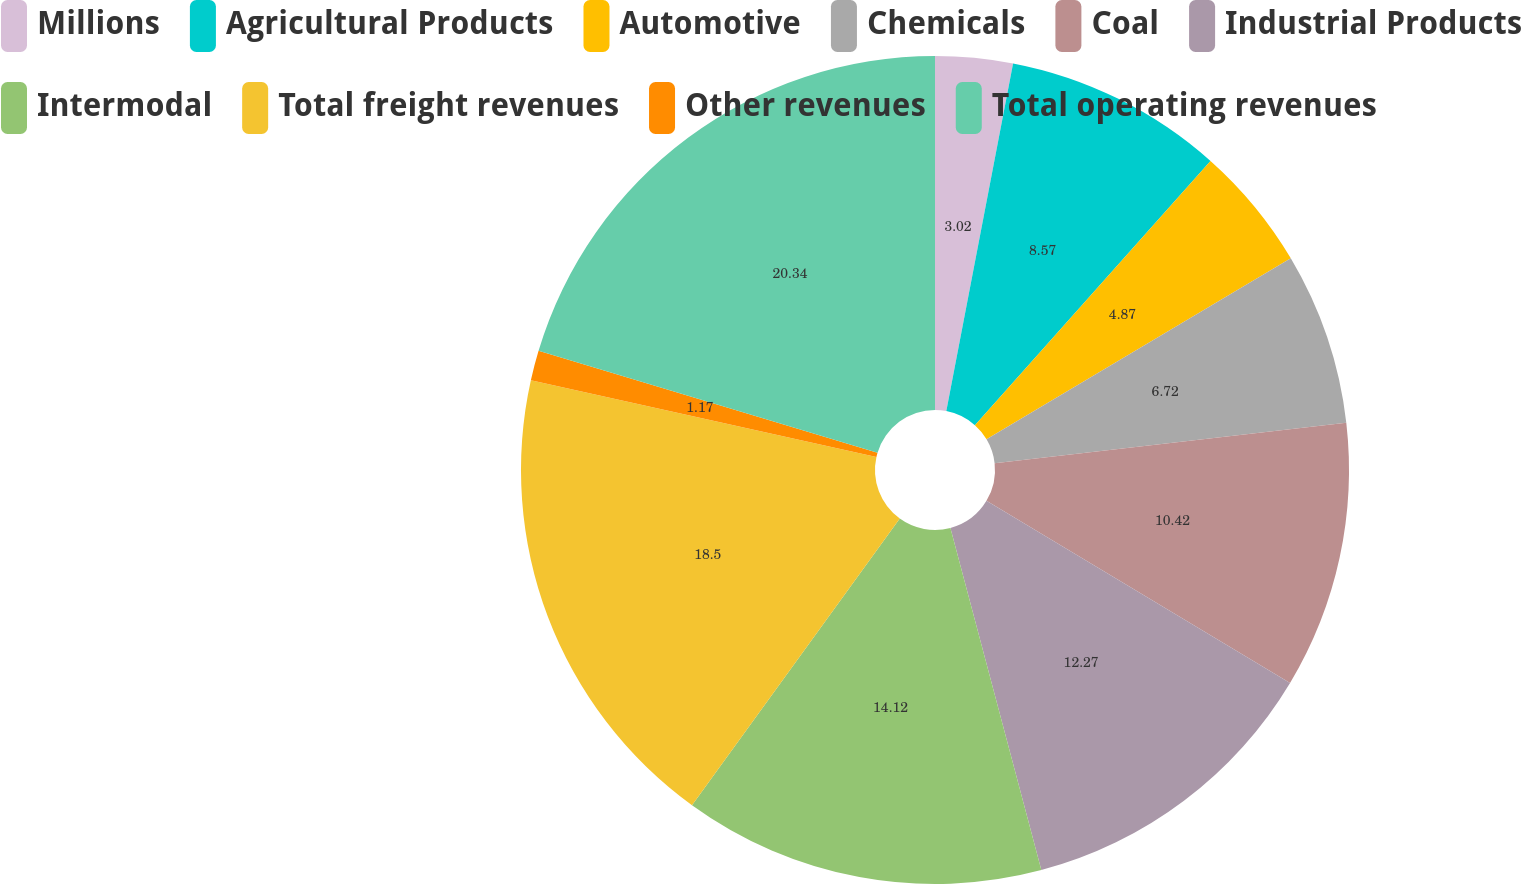Convert chart. <chart><loc_0><loc_0><loc_500><loc_500><pie_chart><fcel>Millions<fcel>Agricultural Products<fcel>Automotive<fcel>Chemicals<fcel>Coal<fcel>Industrial Products<fcel>Intermodal<fcel>Total freight revenues<fcel>Other revenues<fcel>Total operating revenues<nl><fcel>3.02%<fcel>8.57%<fcel>4.87%<fcel>6.72%<fcel>10.42%<fcel>12.27%<fcel>14.12%<fcel>18.5%<fcel>1.17%<fcel>20.35%<nl></chart> 